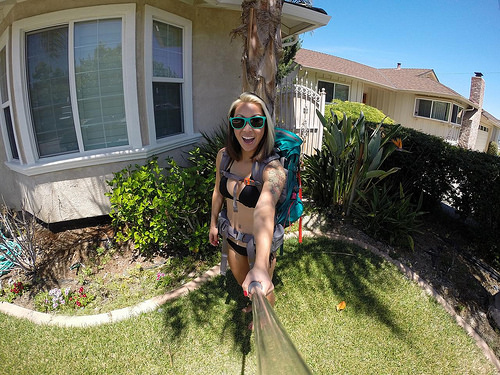<image>
Is the woman next to the house? Yes. The woman is positioned adjacent to the house, located nearby in the same general area. 